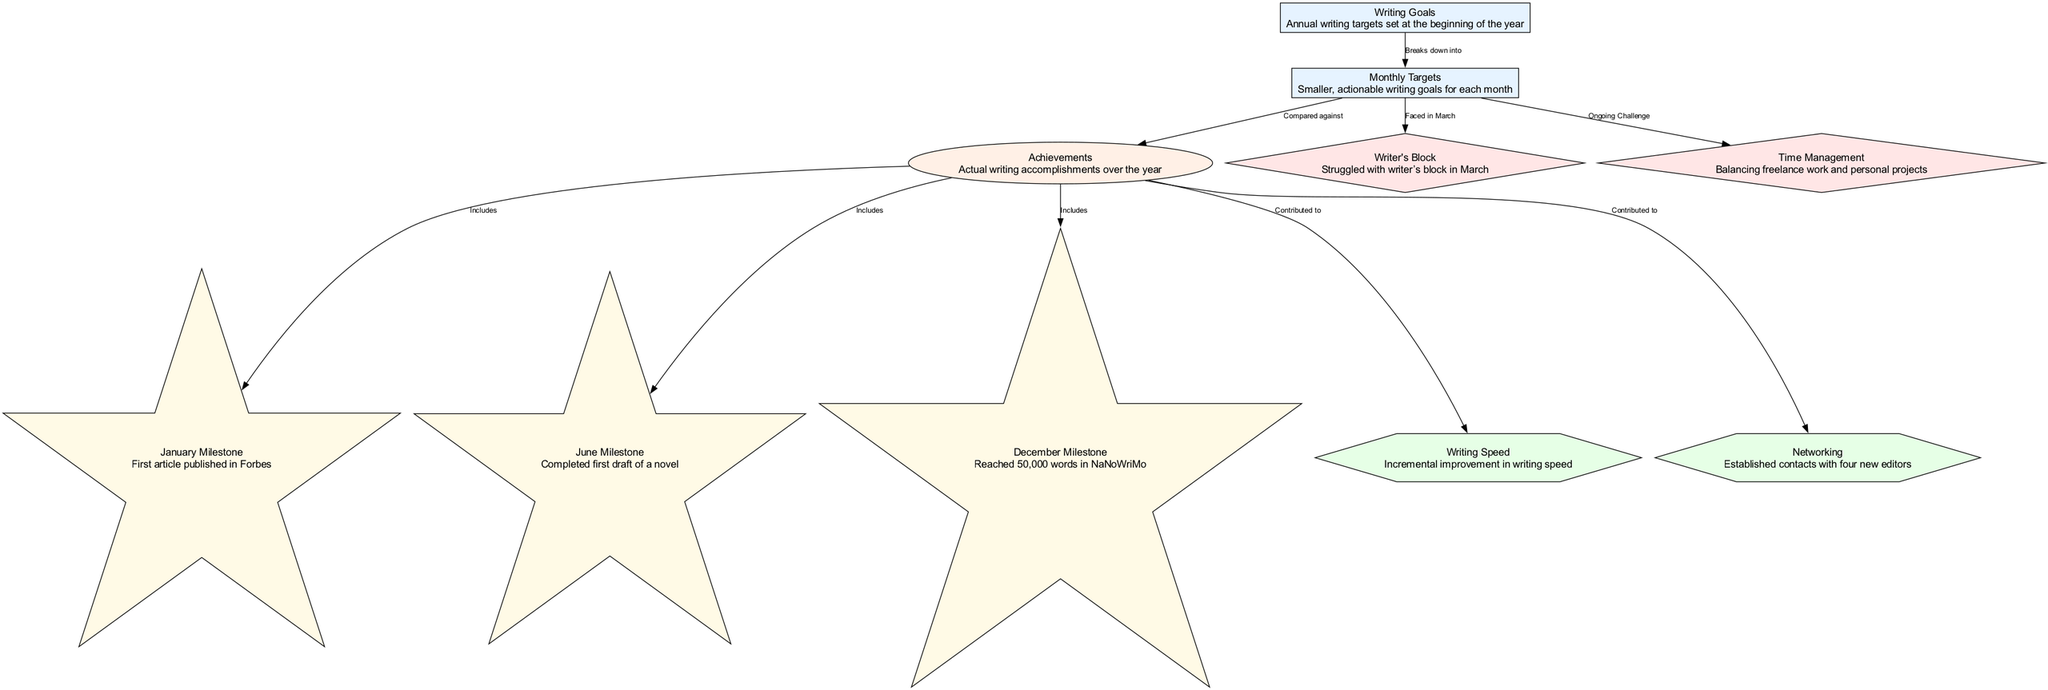What are the main categories represented in the diagram? The diagram includes several categories: Goals, Results, Milestones, Challenges, and Improvements. Each category is assigned different styles and colors, making them distinct within the diagram.
Answer: Goals, Results, Milestones, Challenges, Improvements How many milestones are shown in the diagram? There are three milestones listed in the diagram: January Milestone, June Milestone, and December Milestone. Each milestone corresponds to a significant writing achievement at different times of the year.
Answer: 3 What struggled in March according to the diagram? The diagram indicates Writer's Block as a challenge faced in March, highlighting a specific period where writing progress was impeded.
Answer: Writer's Block What is the result of the writing goals compared against? The diagram shows that Monthly Targets are used to break down Writing Goals, while Actual Writing Accomplishments are what Monthly Targets are compared against as a measure of success.
Answer: Monthly Targets Which improvement is related to networking? The diagram specifies that the networking effort led to the establishment of contacts with four new editors, showing a tangible outcome in the category of Improvements.
Answer: Established contacts with four new editors How does the achievement of reaching 50,000 words fit into the diagram? The achievement of reaching 50,000 words is categorized as a December Milestone and is included within the Actual Writing Accomplishments, indicating a successful end-of-year goal.
Answer: Reached 50,000 words in NaNoWriMo What ongoing challenge is faced throughout the year? The diagram identifies Time Management as an ongoing challenge, indicating that managing time effectively for writing was a continuous issue during the year.
Answer: Time Management What contributed to incremental improvement in writing speed? The diagram illustrates that Actual Writing Accomplishments contributed to an incremental improvement in writing speed, showing a direct correlation between achievements and skill enhancements.
Answer: Incremental improvement in writing speed How does the structure of the diagram show the relationship between goals and challenges? The diagram indicates that Monthly Targets are broken down from Writing Goals and that both Writer's Block and Time Management are challenges faced when trying to achieve those goals, showcasing the relationship between targets and hurdles.
Answer: Monthly Targets, Writer's Block, Time Management 